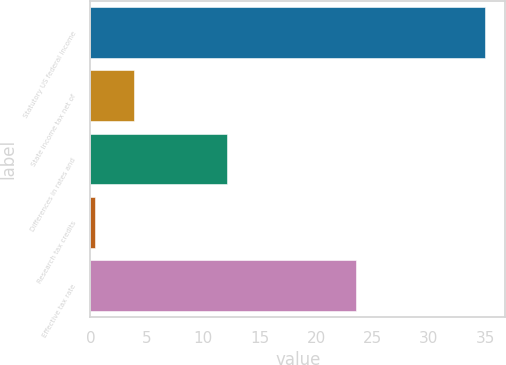Convert chart to OTSL. <chart><loc_0><loc_0><loc_500><loc_500><bar_chart><fcel>Statutory US federal income<fcel>State income tax net of<fcel>Differences in rates and<fcel>Research tax credits<fcel>Effective tax rate<nl><fcel>35<fcel>3.86<fcel>12.1<fcel>0.4<fcel>23.5<nl></chart> 